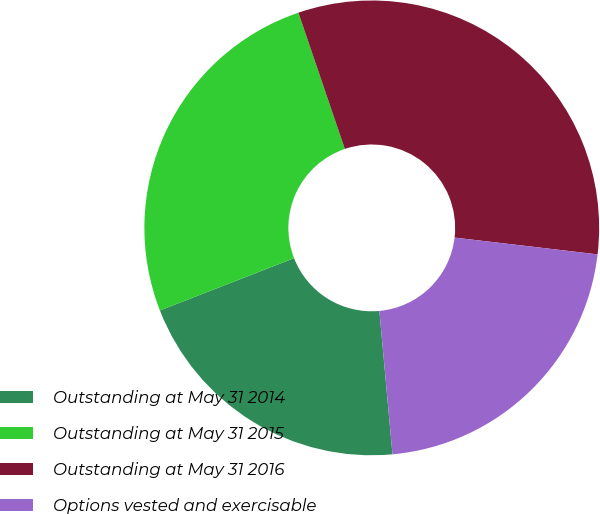Convert chart to OTSL. <chart><loc_0><loc_0><loc_500><loc_500><pie_chart><fcel>Outstanding at May 31 2014<fcel>Outstanding at May 31 2015<fcel>Outstanding at May 31 2016<fcel>Options vested and exercisable<nl><fcel>20.54%<fcel>25.69%<fcel>32.09%<fcel>21.69%<nl></chart> 